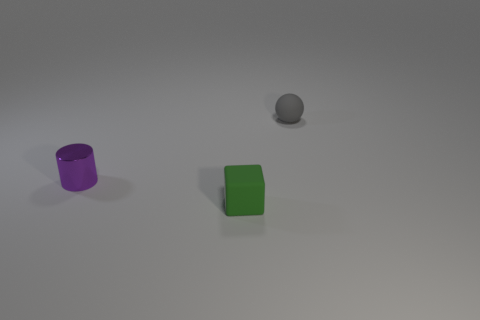Add 1 small green metal objects. How many objects exist? 4 Subtract all red cubes. Subtract all red balls. How many cubes are left? 1 Subtract all cyan cubes. How many green cylinders are left? 0 Subtract all green things. Subtract all big red metal spheres. How many objects are left? 2 Add 3 green matte things. How many green matte things are left? 4 Add 1 spheres. How many spheres exist? 2 Subtract 0 cyan cylinders. How many objects are left? 3 Subtract all balls. How many objects are left? 2 Subtract 1 cylinders. How many cylinders are left? 0 